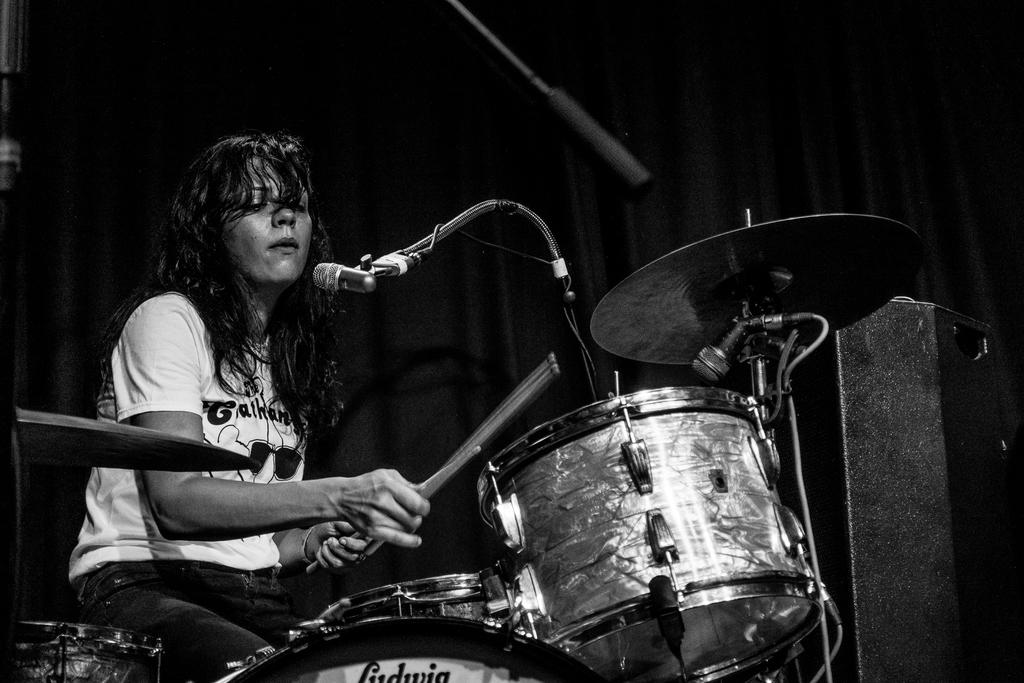What musical instruments are visible in the image? There are drums in the bottom right side of the image. What equipment is used for amplifying sound in the image? There is a microphone in the bottom right side of the image. Where is the woman located in the image? The woman is sitting in the bottom left side of the image. What is the woman holding in the image? The woman is holding drum sticks. What is behind the woman in the image? There is a curtain behind the woman. Can you tell me how many eggs are in the woman's pocket in the image? There is no mention of eggs or pockets in the image, so it is not possible to answer that question. 